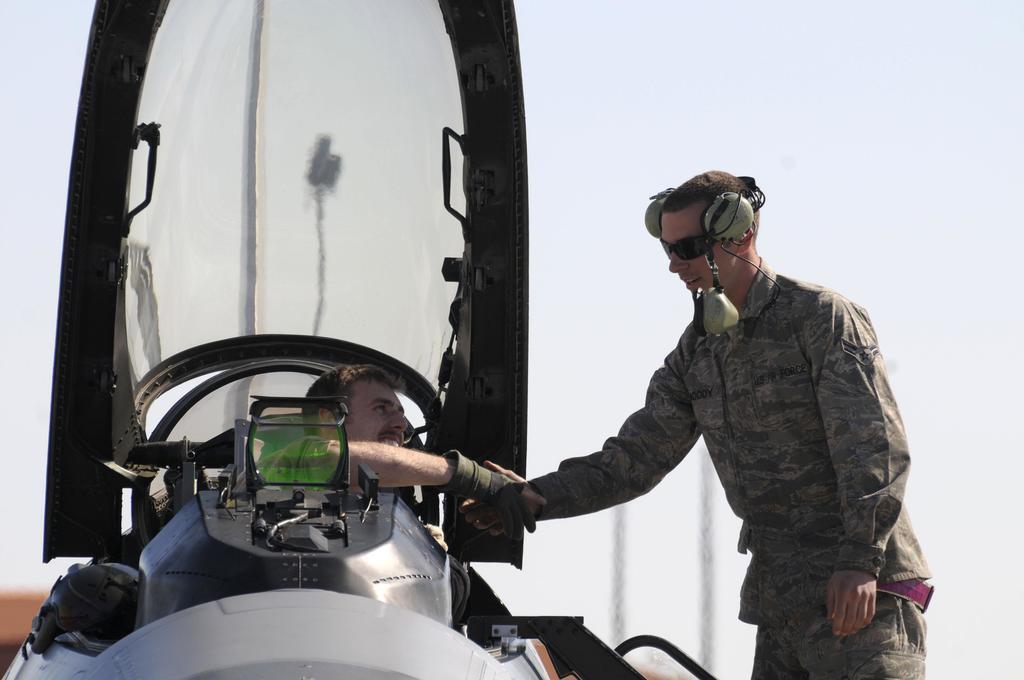How would you summarize this image in a sentence or two? In this image, on the right side, we can see a man standing and wearing a headset and the man is also standing in front of a vehicle. In the vehicle, we can see a person sitting and holding the hand of a another person. In the background, we can see a sky and two poles. 